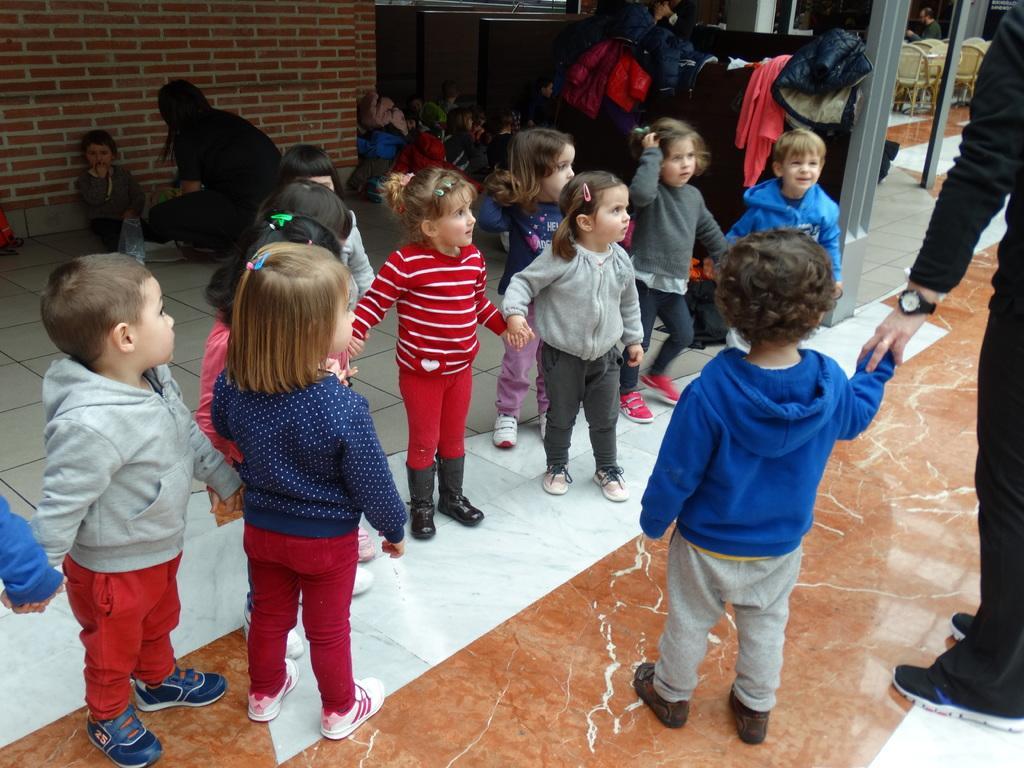Please provide a concise description of this image. On the right side a kid is standing, this kid wore blue color sweater, on the left side a group of children are standing by joining their hands together, there is a brick wall on left side in this image. 